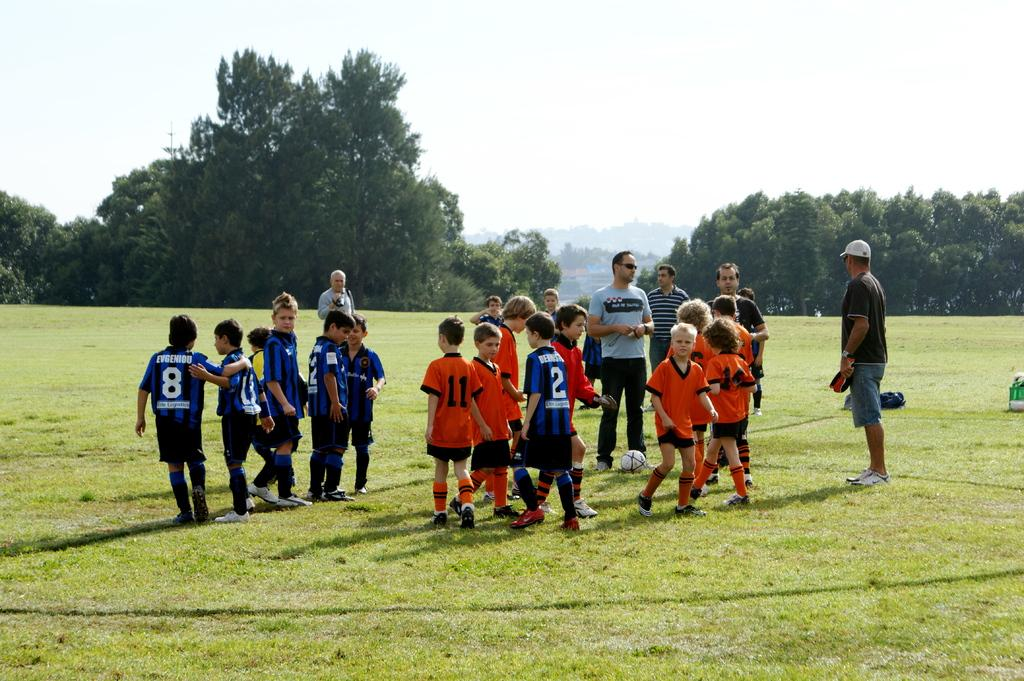Who is present in the image? There are children in the image. What is the surface the children are standing on? The children are standing on a grass surface. What type of clothing are the children wearing? The children are wearing sportswear. What can be seen in the background of the image? There are trees, hills, and the sky visible in the background of the image. What type of linen is draped over the children in the image? There is no linen draped over the children in the image; they are wearing sportswear. What color is the silver object in the image? There is no silver object present in the image. 